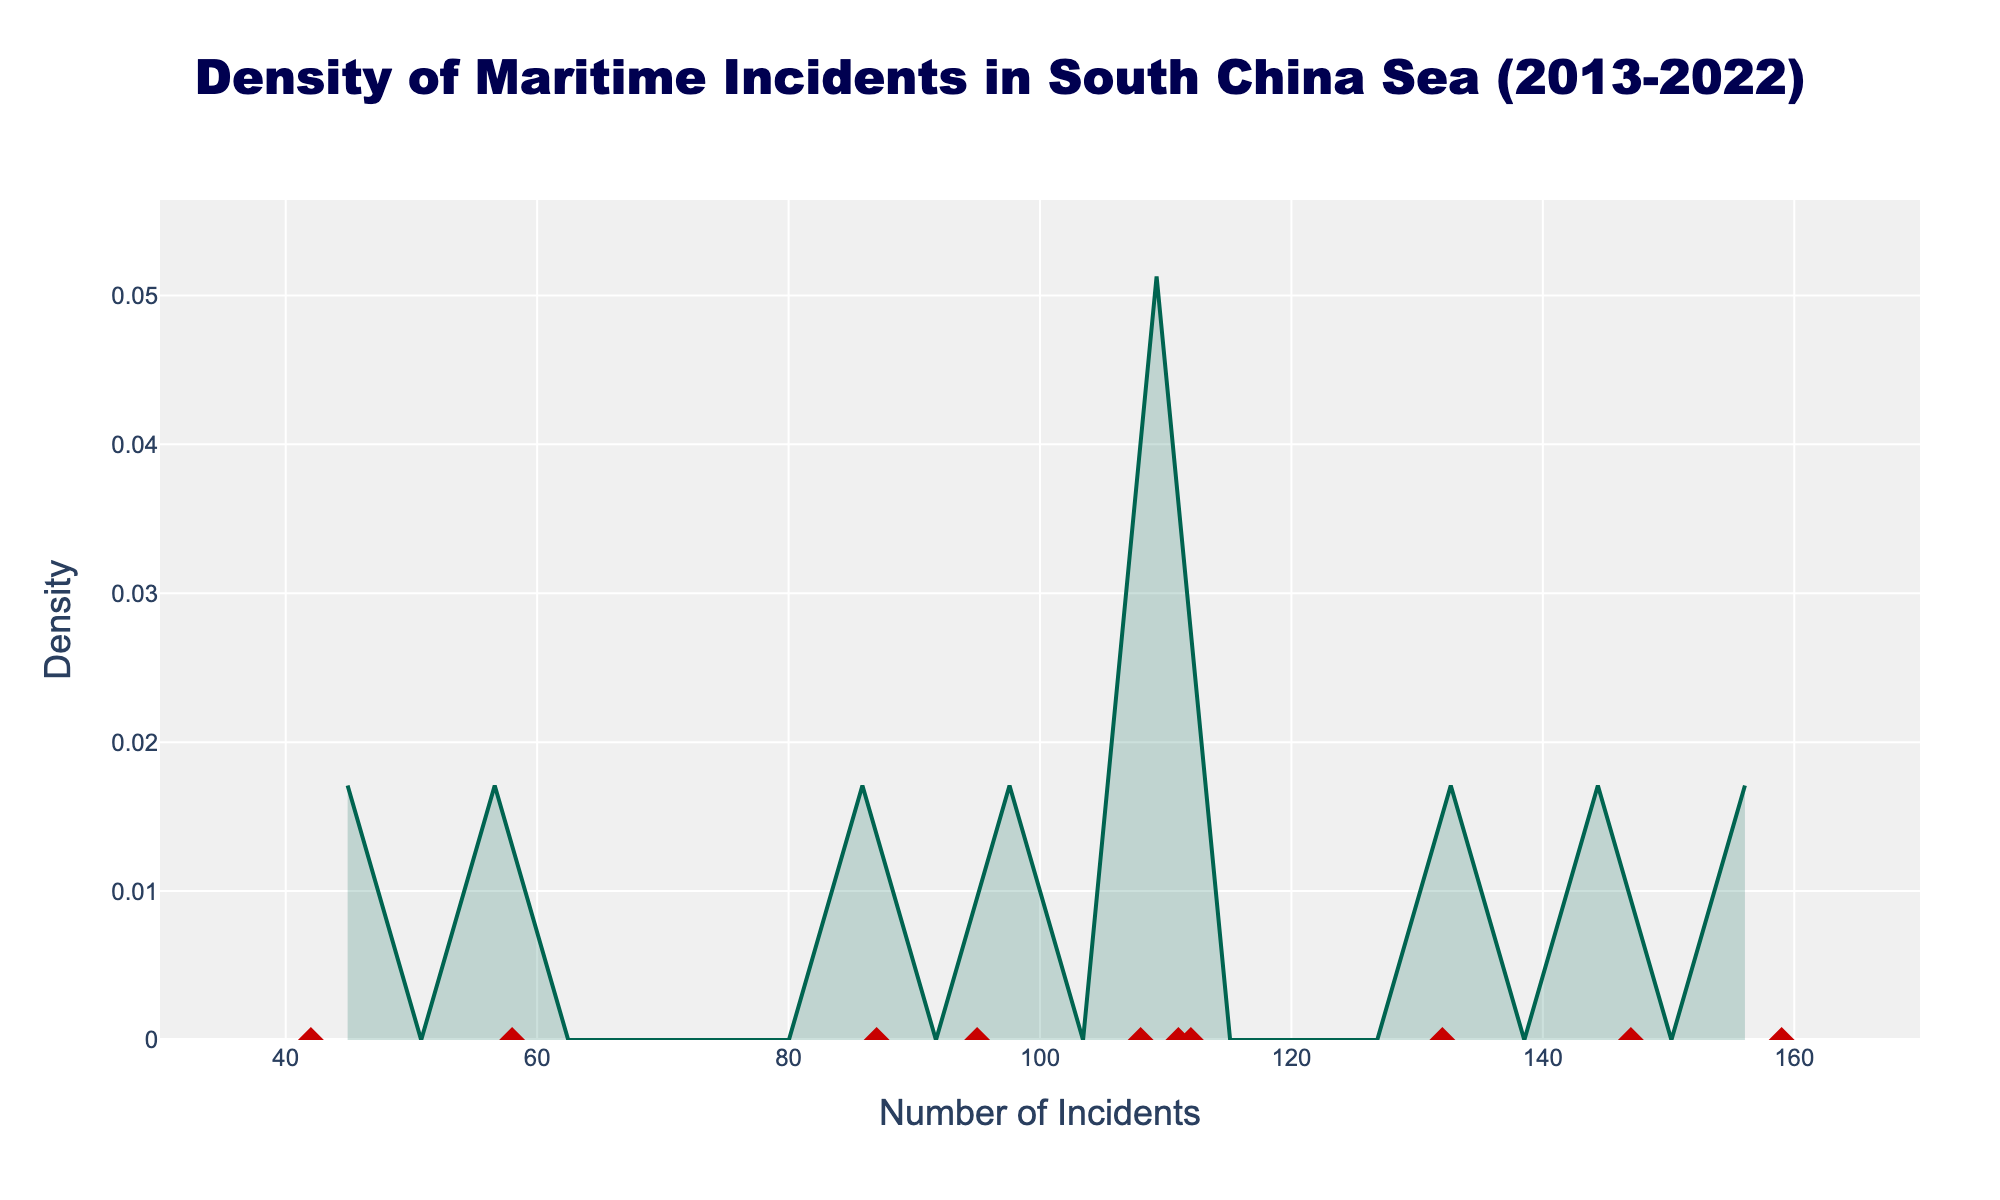What is the title of the figure? The title of the figure is usually located at the top and provides context regarding the data being displayed. In this case, the title reads "Density of Maritime Incidents in South China Sea (2013-2022)."
Answer: Density of Maritime Incidents in South China Sea (2013-2022) What is the maximum value on the x-axis? The x-axis usually indicates the range of incidents. From the figure, you can see the x-axis ranges from about 30 to 170. The maximum value is the rightmost number on this axis.
Answer: 170 How many data points are represented by the red diamond markers on the plot? The number of red diamond markers corresponds to the number of years of data points shown. Counting each red diamond gives us a total of 10 data points.
Answer: 10 What is the peak density value shown on the y-axis? The highest point on the density curve represents the peak density. By observing the y-axis and the peak of the density plot, we can identify this highest density value.
Answer: Around 0.015 Which year had the highest number of maritime incidents? The red diamond markers on the plot represent each year's data. The location of the rightmost red diamond on the x-axis signifies the year with the highest number of incidents. Observing the x-axis, this point corresponds to the year 2022.
Answer: 2022 What is the approximate range of incident numbers covered by the main density curve? The main density curve starts to rise around the x-axis value of 40 and tapers off close to 160. These values show the approximate range of incident numbers with significant density.
Answer: 40 to 160 How does the number of incidents in 2019 compare to 2017? By locating 2019 and 2017 on the x-axis and observing the red diamond markers, we can compare the values. We can see that 2019 falls further right on the x-axis compared to 2017, indicating a higher number of incidents in 2019.
Answer: Higher in 2019 What can be inferred about the trend in maritime incidents over the decade from 2013-2022? Observing the progression of the red diamond markers from left to right, we notice an overall rightward shift, indicating an increase in the number of incidents annually. Additionally, the density curve shows higher densities toward the higher incident values.
Answer: Increasing trend How do the incidents in 2020 compare to 2021? By observing the data points for these years on the x-axis, we can see the 2021 marker is further right compared to 2020, indicating an increase in incidents in 2021 compared to 2020.
Answer: Higher in 2021 What's the density value when the number of incidents is around 100? To find the density value corresponding to an incident count around 100, we look at the height of the density curve above the 100 mark on the x-axis. The corresponding y-axis value reveals the density.
Answer: Approximately 0.01 